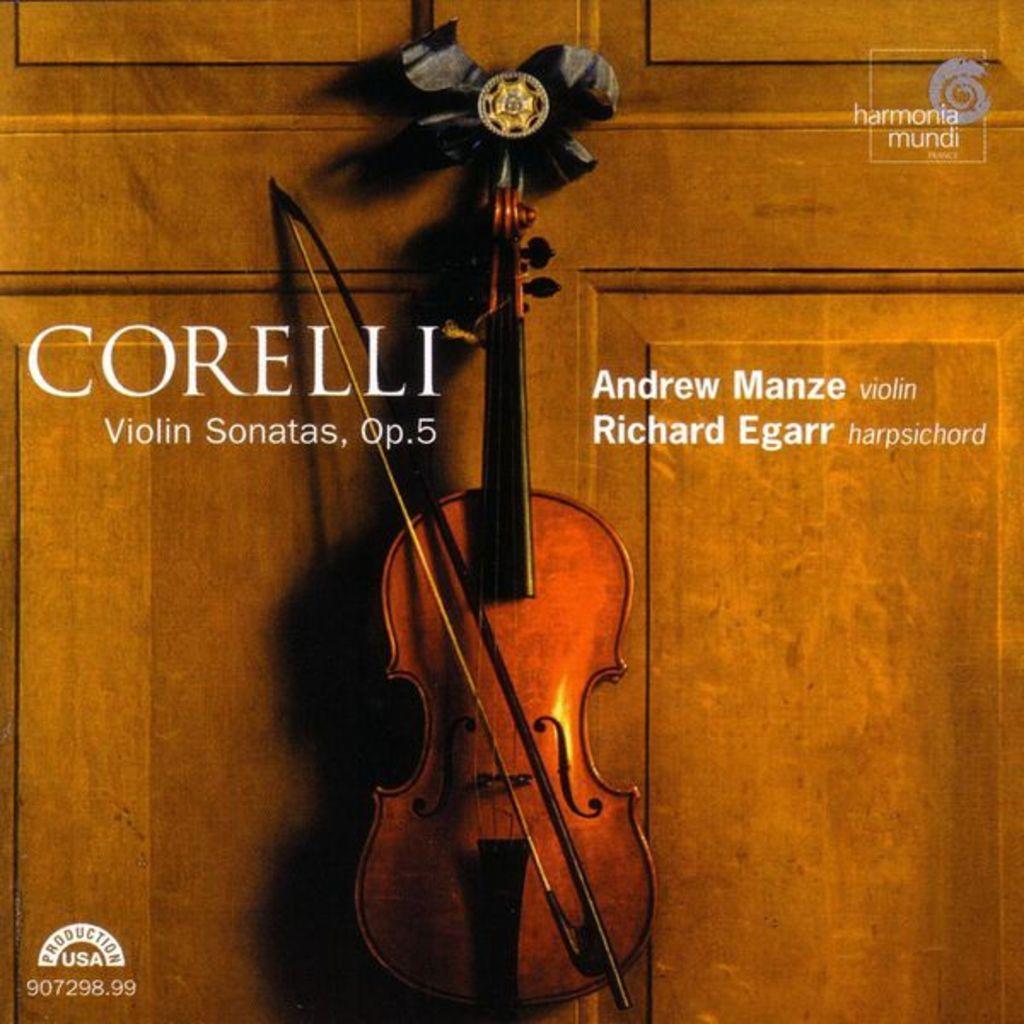Could you give a brief overview of what you see in this image? In the image we can see there is a poster of a violin and the name is written "CORELLI" and the name of the violin is "andrew manze". 